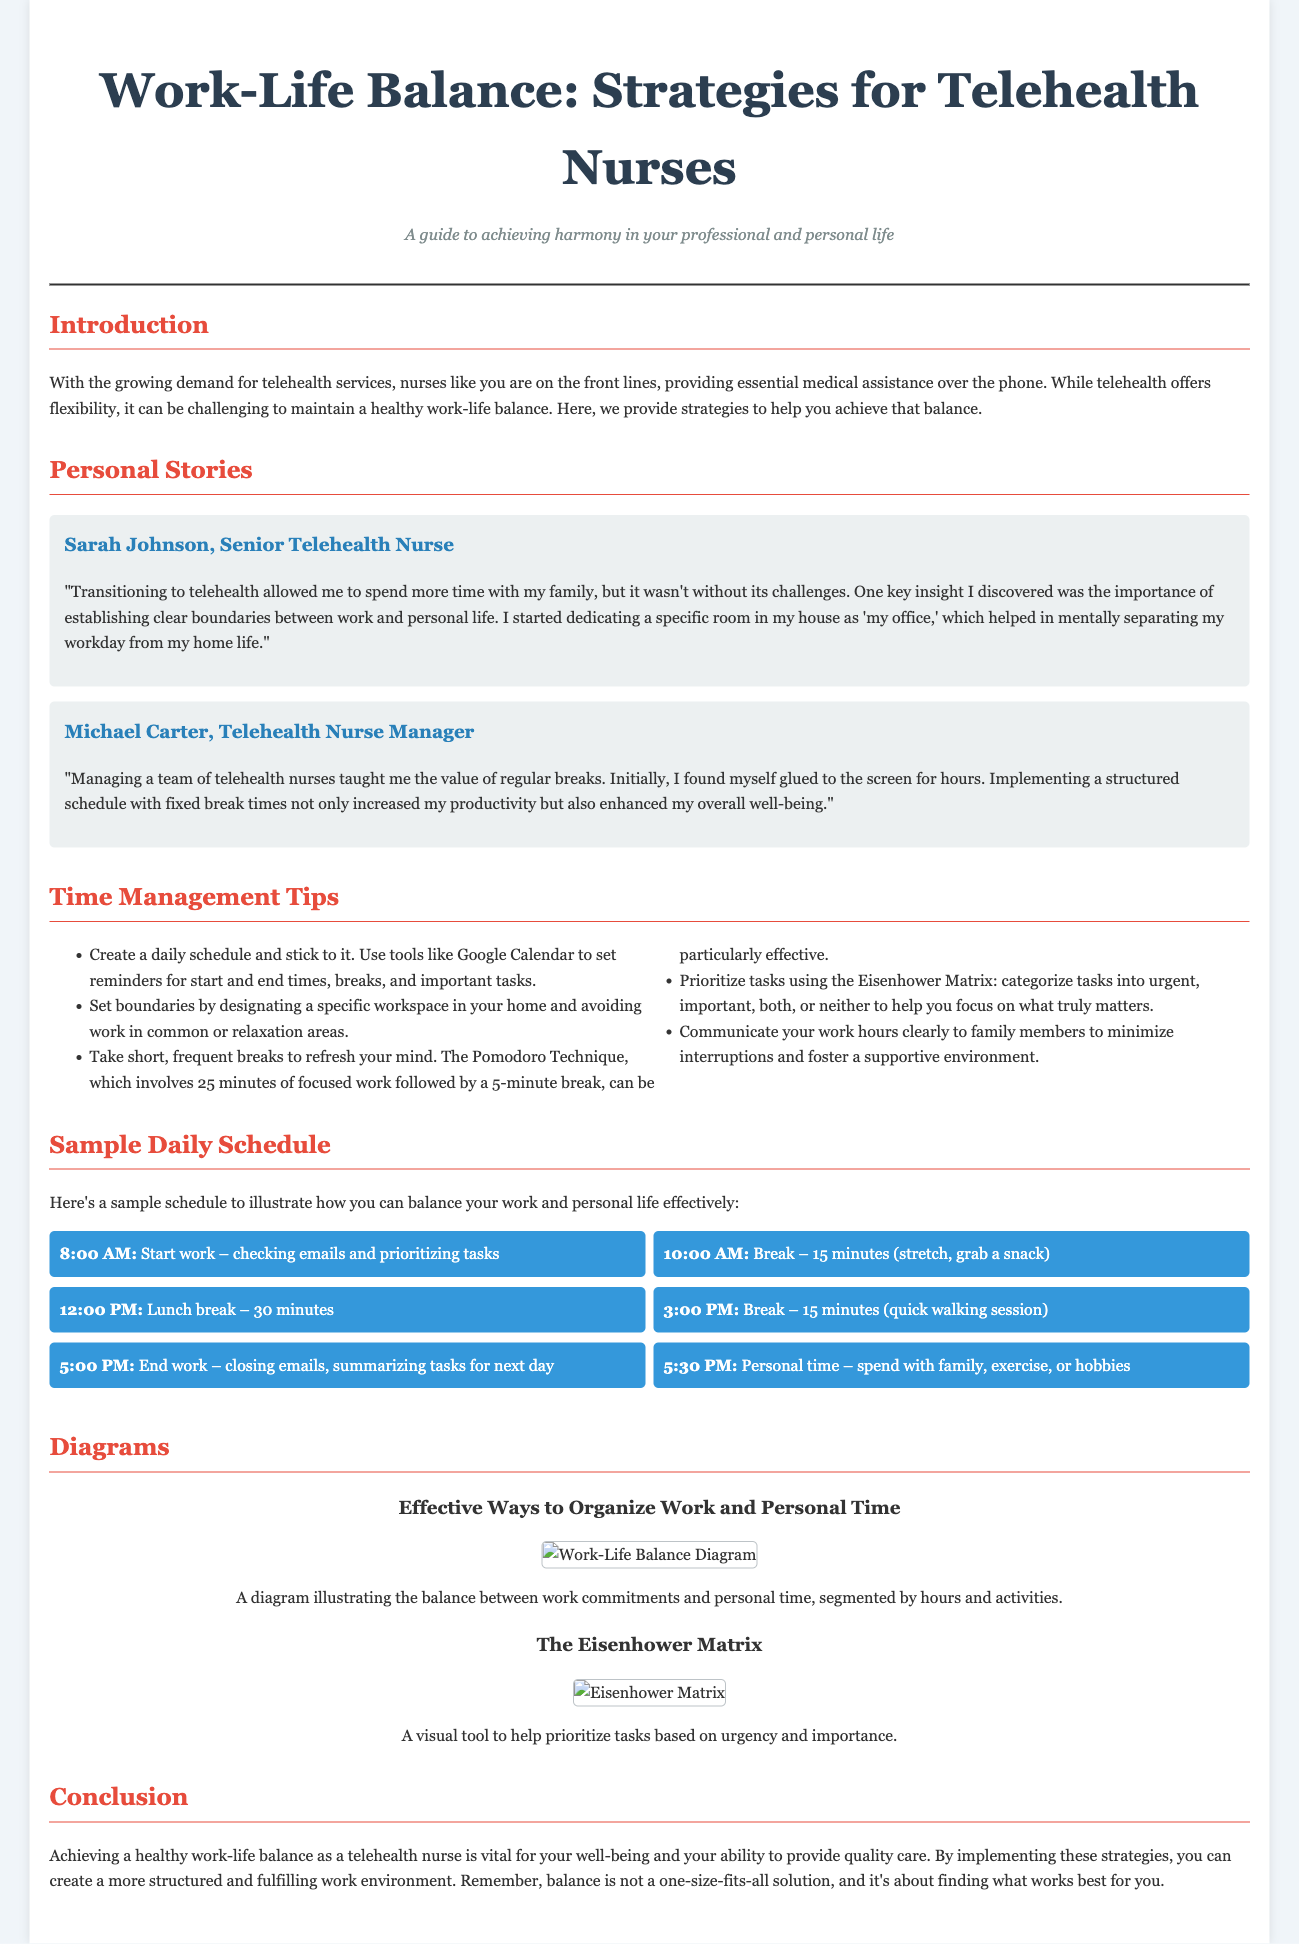What is the title of the article? The title of the article is found at the beginning of the document.
Answer: Work-Life Balance: Strategies for Telehealth Nurses Who shared a personal story about work-life balance? Personal stories are shared by individuals, and one of them is Sarah Johnson.
Answer: Sarah Johnson What time does the sample schedule suggest a telehealth nurse should start work? The sample schedule specifies a starting time for work.
Answer: 8:00 AM What technique is recommended for taking breaks? The document mentions a specific technique for taking breaks.
Answer: The Pomodoro Technique What color is used for the main headers in the document? The color of the main headers is specifically stated in the styling section.
Answer: #e74c3c What is recommended for prioritizing tasks? A method is suggested for organizing tasks by urgency and importance.
Answer: The Eisenhower Matrix How long is the lunch break in the sample schedule? The duration of the lunch break is noted in the schedule.
Answer: 30 minutes Which personal strategy helped Sarah Johnson in her work-life balance? Sarah Johnson's strategy for managing work-life balance is mentioned in her story.
Answer: Establishing clear boundaries What is the main purpose of this document? The main purpose is clarified in the introduction of the document.
Answer: To achieve harmony in your professional and personal life 